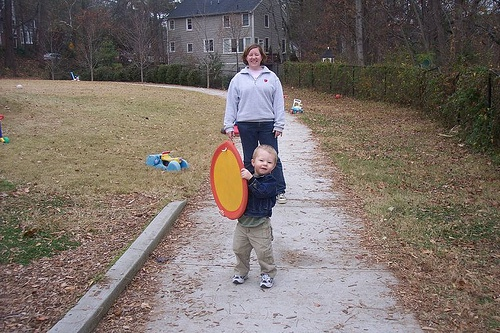Describe the objects in this image and their specific colors. I can see people in black, lavender, and navy tones, people in black, gray, darkgray, and navy tones, frisbee in black, orange, salmon, and brown tones, people in black, gray, and navy tones, and car in black and gray tones in this image. 